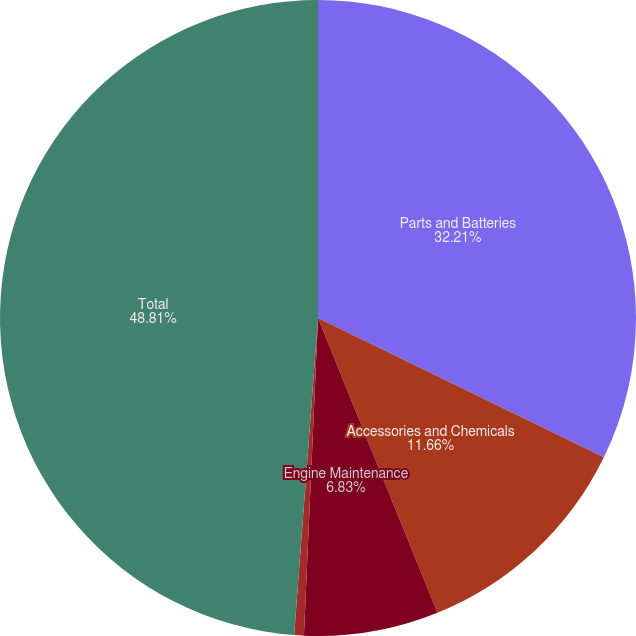Convert chart to OTSL. <chart><loc_0><loc_0><loc_500><loc_500><pie_chart><fcel>Parts and Batteries<fcel>Accessories and Chemicals<fcel>Engine Maintenance<fcel>Other<fcel>Total<nl><fcel>32.21%<fcel>11.66%<fcel>6.83%<fcel>0.49%<fcel>48.8%<nl></chart> 